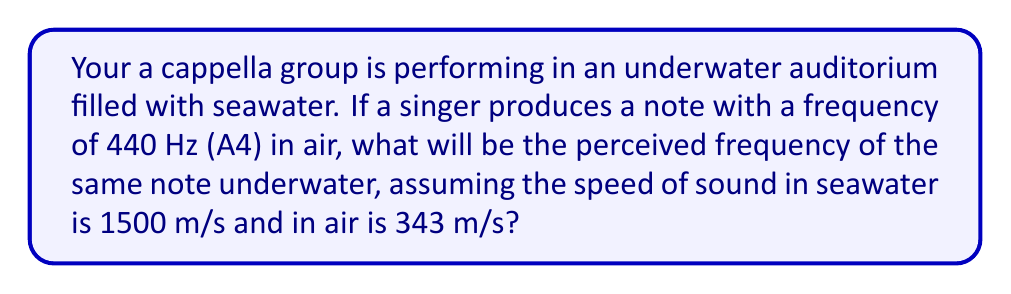Help me with this question. To solve this problem, we need to understand how the speed of sound in different mediums affects the perceived pitch. The relationship between frequency (f), wavelength (λ), and speed of sound (v) is given by:

$$v = f \lambda$$

1. In air:
   $$v_{air} = f_{air} \lambda_{air}$$
   $$343 = 440 \lambda_{air}$$
   $$\lambda_{air} = \frac{343}{440} \approx 0.78 \text{ m}$$

2. The wavelength remains constant when the sound wave transitions between mediums. So, $\lambda_{seawater} = \lambda_{air} = 0.78 \text{ m}$

3. In seawater:
   $$v_{seawater} = f_{seawater} \lambda_{seawater}$$
   $$1500 = f_{seawater} \cdot 0.78$$
   $$f_{seawater} = \frac{1500}{0.78} \approx 1923.08 \text{ Hz}$$

Therefore, the perceived frequency of the note underwater will be approximately 1923.08 Hz.
Answer: 1923.08 Hz 